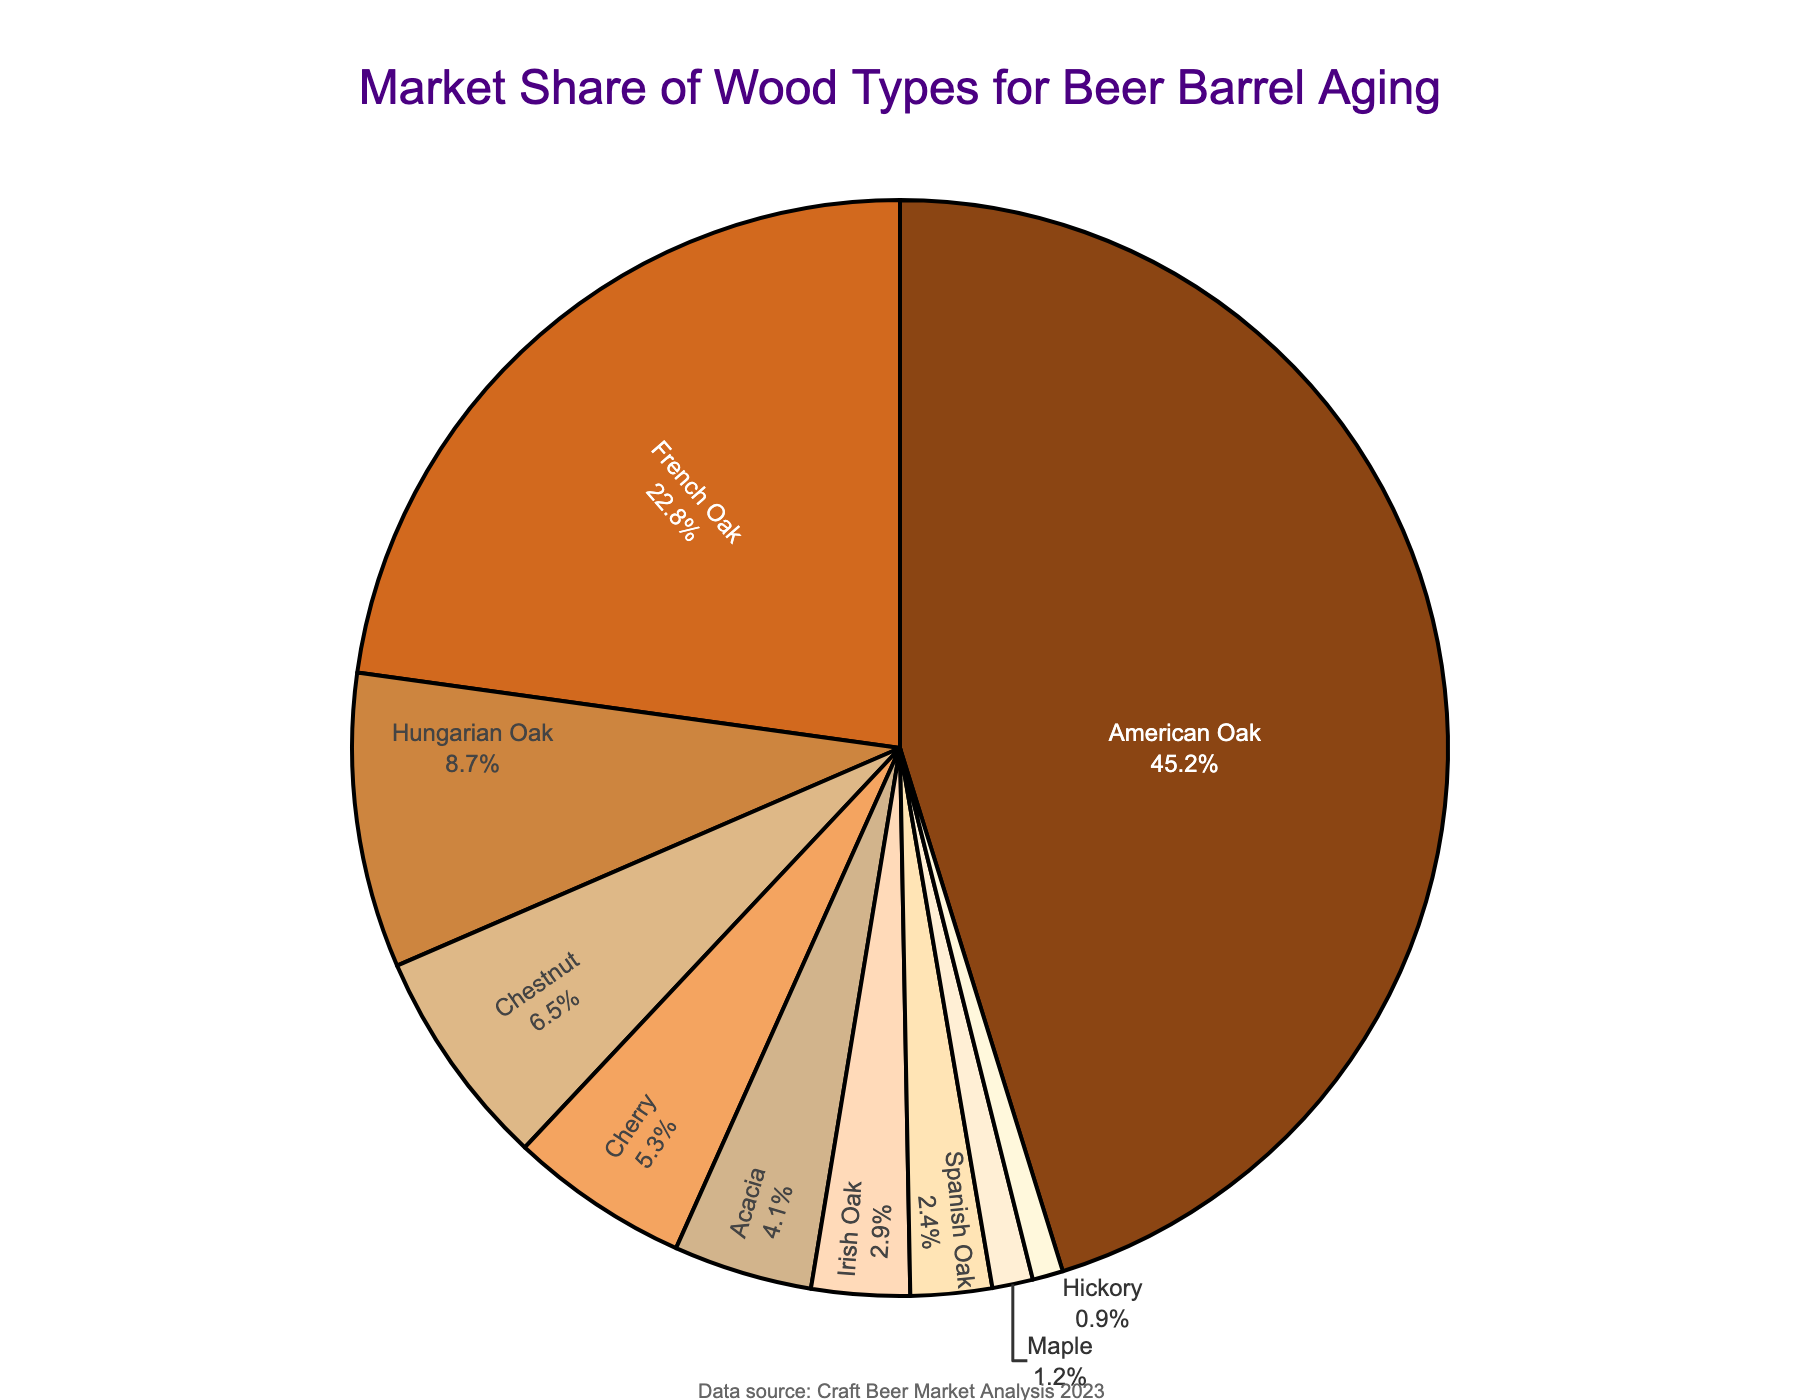Which wood type holds the largest market share? Look at the pie chart and find the section with the largest slice. The label states that American Oak holds the largest market share.
Answer: American Oak Which three wood types have the smallest market shares? Examine the pie chart for the smallest slices. The labels of those three slices are Maple, Hickory, and Spanish Oak.
Answer: Maple, Hickory, Spanish Oak What is the combined market share of Hungarian Oak and Cherry? Add the market shares of Hungarian Oak (8.7) and Cherry (5.3). The sum is 8.7 + 5.3 = 14.
Answer: 14 How much greater is the market share of American Oak compared to French Oak? Subtract the market share of French Oak (22.8) from the market share of American Oak (45.2). The difference is 45.2 - 22.8 = 22.4.
Answer: 22.4 Which wood type has a market share closest to 5%? Look for the slice labeled "5.3%" in the pie chart, which corresponds to Cherry.
Answer: Cherry Is Chestnut's market share higher or lower than 7%? Find the Chestnut segment in the pie chart. Its label reads 6.5%, which is lower than 7%.
Answer: Lower What is the average market share of the top three wood types? First, identify the top three wood types: American Oak (45.2), French Oak (22.8), and Hungarian Oak (8.7). Then calculate the average: (45.2 + 22.8 + 8.7) / 3 = 25.57.
Answer: 25.57 If the market for American Oak decreases by 5%, what would its new market share be? Subtract 5% from 45.2% to get the new market share: 45.2 - 5 = 40.2.
Answer: 40.2 What percentage of the market is shared by all oak types (American, French, Hungarian, Irish, and Spanish)? Add the market shares: 45.2 (American) + 22.8 (French) + 8.7 (Hungarian) + 2.9 (Irish) + 2.4 (Spanish) = 82.
Answer: 82 